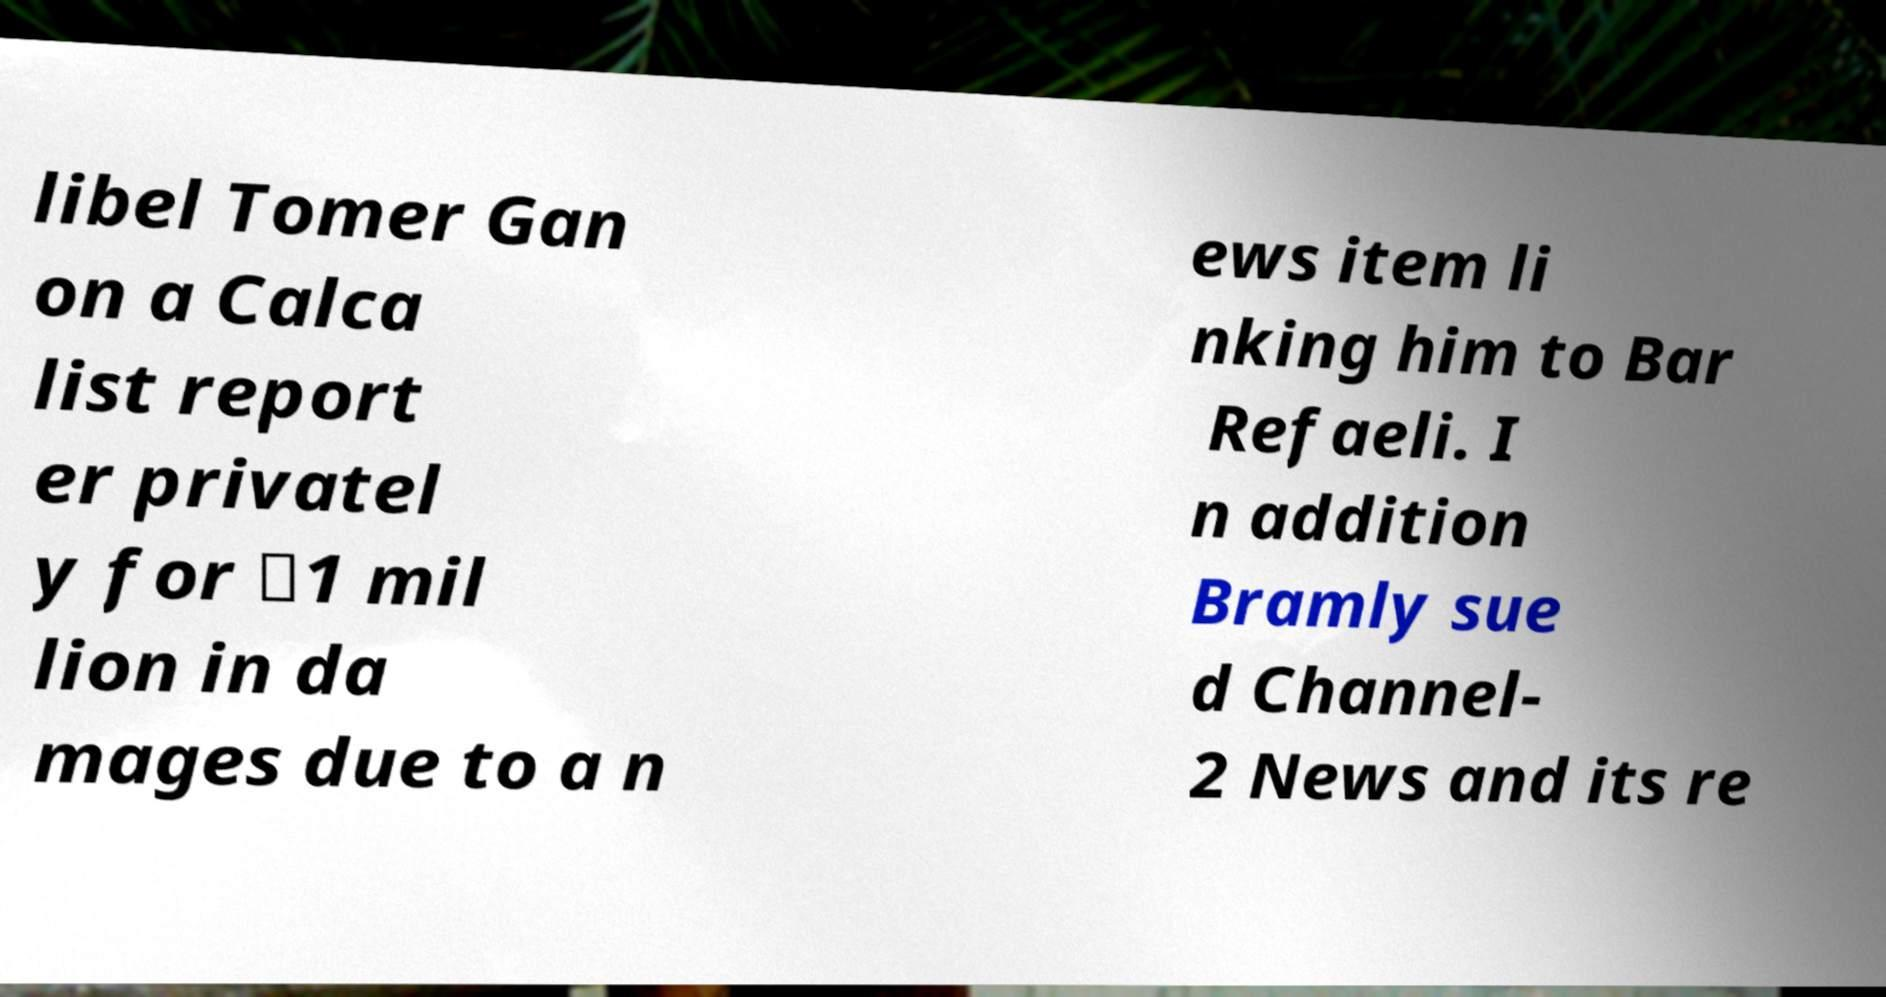Could you assist in decoding the text presented in this image and type it out clearly? libel Tomer Gan on a Calca list report er privatel y for ₪1 mil lion in da mages due to a n ews item li nking him to Bar Refaeli. I n addition Bramly sue d Channel- 2 News and its re 